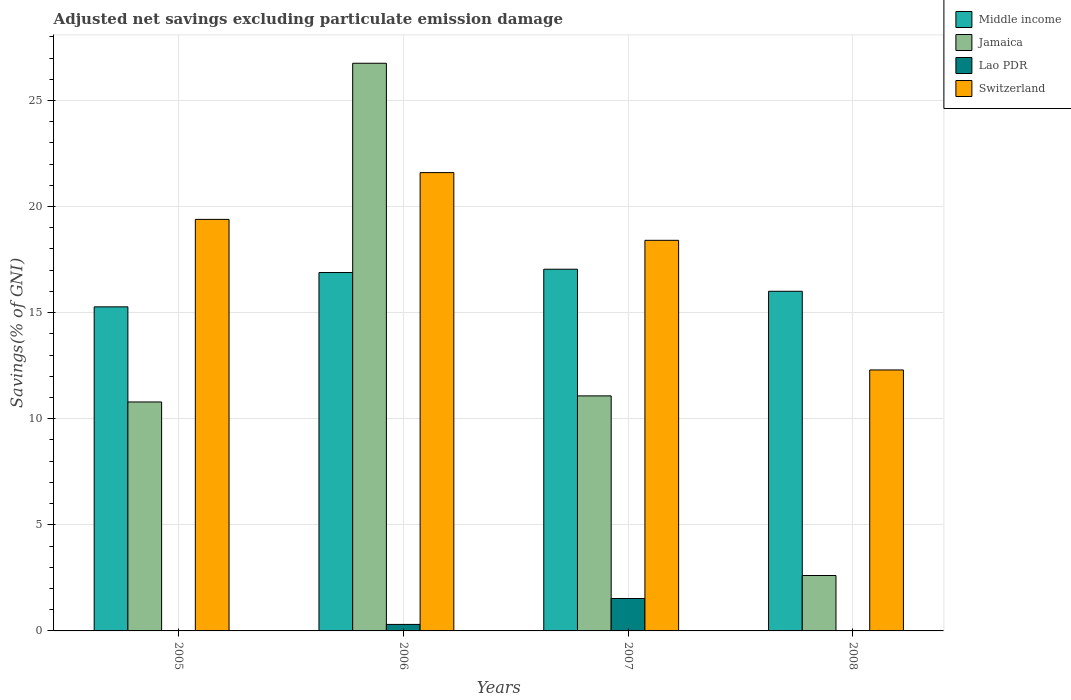How many groups of bars are there?
Your response must be concise. 4. Are the number of bars on each tick of the X-axis equal?
Provide a short and direct response. No. How many bars are there on the 1st tick from the right?
Your response must be concise. 3. In how many cases, is the number of bars for a given year not equal to the number of legend labels?
Provide a succinct answer. 2. What is the adjusted net savings in Switzerland in 2007?
Your answer should be very brief. 18.41. Across all years, what is the maximum adjusted net savings in Switzerland?
Make the answer very short. 21.6. Across all years, what is the minimum adjusted net savings in Jamaica?
Ensure brevity in your answer.  2.61. In which year was the adjusted net savings in Jamaica maximum?
Provide a short and direct response. 2006. What is the total adjusted net savings in Middle income in the graph?
Offer a very short reply. 65.22. What is the difference between the adjusted net savings in Jamaica in 2005 and that in 2007?
Give a very brief answer. -0.29. What is the difference between the adjusted net savings in Jamaica in 2008 and the adjusted net savings in Middle income in 2006?
Offer a terse response. -14.28. What is the average adjusted net savings in Jamaica per year?
Your response must be concise. 12.81. In the year 2006, what is the difference between the adjusted net savings in Jamaica and adjusted net savings in Middle income?
Your answer should be very brief. 9.86. In how many years, is the adjusted net savings in Middle income greater than 25 %?
Ensure brevity in your answer.  0. What is the ratio of the adjusted net savings in Middle income in 2006 to that in 2008?
Offer a terse response. 1.06. Is the adjusted net savings in Jamaica in 2005 less than that in 2006?
Your answer should be very brief. Yes. What is the difference between the highest and the second highest adjusted net savings in Jamaica?
Your answer should be very brief. 15.68. What is the difference between the highest and the lowest adjusted net savings in Middle income?
Your answer should be very brief. 1.77. Is it the case that in every year, the sum of the adjusted net savings in Switzerland and adjusted net savings in Middle income is greater than the sum of adjusted net savings in Lao PDR and adjusted net savings in Jamaica?
Your answer should be very brief. No. Is it the case that in every year, the sum of the adjusted net savings in Middle income and adjusted net savings in Switzerland is greater than the adjusted net savings in Lao PDR?
Your response must be concise. Yes. Are all the bars in the graph horizontal?
Ensure brevity in your answer.  No. What is the difference between two consecutive major ticks on the Y-axis?
Ensure brevity in your answer.  5. Does the graph contain any zero values?
Make the answer very short. Yes. Does the graph contain grids?
Give a very brief answer. Yes. How are the legend labels stacked?
Provide a succinct answer. Vertical. What is the title of the graph?
Your answer should be compact. Adjusted net savings excluding particulate emission damage. What is the label or title of the Y-axis?
Provide a succinct answer. Savings(% of GNI). What is the Savings(% of GNI) in Middle income in 2005?
Offer a terse response. 15.27. What is the Savings(% of GNI) in Jamaica in 2005?
Keep it short and to the point. 10.79. What is the Savings(% of GNI) of Switzerland in 2005?
Provide a short and direct response. 19.4. What is the Savings(% of GNI) of Middle income in 2006?
Ensure brevity in your answer.  16.89. What is the Savings(% of GNI) of Jamaica in 2006?
Your answer should be compact. 26.75. What is the Savings(% of GNI) in Lao PDR in 2006?
Provide a short and direct response. 0.31. What is the Savings(% of GNI) in Switzerland in 2006?
Your response must be concise. 21.6. What is the Savings(% of GNI) in Middle income in 2007?
Provide a short and direct response. 17.05. What is the Savings(% of GNI) of Jamaica in 2007?
Offer a very short reply. 11.08. What is the Savings(% of GNI) in Lao PDR in 2007?
Your answer should be very brief. 1.53. What is the Savings(% of GNI) of Switzerland in 2007?
Make the answer very short. 18.41. What is the Savings(% of GNI) of Middle income in 2008?
Your answer should be compact. 16.01. What is the Savings(% of GNI) of Jamaica in 2008?
Ensure brevity in your answer.  2.61. What is the Savings(% of GNI) in Switzerland in 2008?
Provide a succinct answer. 12.3. Across all years, what is the maximum Savings(% of GNI) of Middle income?
Your answer should be compact. 17.05. Across all years, what is the maximum Savings(% of GNI) in Jamaica?
Your answer should be compact. 26.75. Across all years, what is the maximum Savings(% of GNI) of Lao PDR?
Offer a very short reply. 1.53. Across all years, what is the maximum Savings(% of GNI) in Switzerland?
Your answer should be compact. 21.6. Across all years, what is the minimum Savings(% of GNI) in Middle income?
Give a very brief answer. 15.27. Across all years, what is the minimum Savings(% of GNI) in Jamaica?
Offer a terse response. 2.61. Across all years, what is the minimum Savings(% of GNI) of Lao PDR?
Offer a very short reply. 0. Across all years, what is the minimum Savings(% of GNI) of Switzerland?
Ensure brevity in your answer.  12.3. What is the total Savings(% of GNI) in Middle income in the graph?
Make the answer very short. 65.22. What is the total Savings(% of GNI) in Jamaica in the graph?
Give a very brief answer. 51.23. What is the total Savings(% of GNI) in Lao PDR in the graph?
Ensure brevity in your answer.  1.83. What is the total Savings(% of GNI) in Switzerland in the graph?
Offer a terse response. 71.7. What is the difference between the Savings(% of GNI) of Middle income in 2005 and that in 2006?
Your response must be concise. -1.62. What is the difference between the Savings(% of GNI) of Jamaica in 2005 and that in 2006?
Offer a terse response. -15.96. What is the difference between the Savings(% of GNI) in Switzerland in 2005 and that in 2006?
Offer a terse response. -2.2. What is the difference between the Savings(% of GNI) in Middle income in 2005 and that in 2007?
Ensure brevity in your answer.  -1.77. What is the difference between the Savings(% of GNI) of Jamaica in 2005 and that in 2007?
Your response must be concise. -0.29. What is the difference between the Savings(% of GNI) of Switzerland in 2005 and that in 2007?
Offer a very short reply. 0.99. What is the difference between the Savings(% of GNI) in Middle income in 2005 and that in 2008?
Offer a terse response. -0.73. What is the difference between the Savings(% of GNI) of Jamaica in 2005 and that in 2008?
Offer a very short reply. 8.18. What is the difference between the Savings(% of GNI) in Switzerland in 2005 and that in 2008?
Offer a terse response. 7.1. What is the difference between the Savings(% of GNI) of Middle income in 2006 and that in 2007?
Ensure brevity in your answer.  -0.16. What is the difference between the Savings(% of GNI) in Jamaica in 2006 and that in 2007?
Make the answer very short. 15.68. What is the difference between the Savings(% of GNI) in Lao PDR in 2006 and that in 2007?
Your answer should be compact. -1.22. What is the difference between the Savings(% of GNI) in Switzerland in 2006 and that in 2007?
Provide a short and direct response. 3.19. What is the difference between the Savings(% of GNI) in Middle income in 2006 and that in 2008?
Your answer should be compact. 0.88. What is the difference between the Savings(% of GNI) of Jamaica in 2006 and that in 2008?
Ensure brevity in your answer.  24.14. What is the difference between the Savings(% of GNI) of Switzerland in 2006 and that in 2008?
Give a very brief answer. 9.3. What is the difference between the Savings(% of GNI) of Middle income in 2007 and that in 2008?
Give a very brief answer. 1.04. What is the difference between the Savings(% of GNI) of Jamaica in 2007 and that in 2008?
Keep it short and to the point. 8.47. What is the difference between the Savings(% of GNI) of Switzerland in 2007 and that in 2008?
Offer a very short reply. 6.11. What is the difference between the Savings(% of GNI) of Middle income in 2005 and the Savings(% of GNI) of Jamaica in 2006?
Keep it short and to the point. -11.48. What is the difference between the Savings(% of GNI) in Middle income in 2005 and the Savings(% of GNI) in Lao PDR in 2006?
Your response must be concise. 14.97. What is the difference between the Savings(% of GNI) of Middle income in 2005 and the Savings(% of GNI) of Switzerland in 2006?
Your answer should be very brief. -6.33. What is the difference between the Savings(% of GNI) in Jamaica in 2005 and the Savings(% of GNI) in Lao PDR in 2006?
Your answer should be compact. 10.48. What is the difference between the Savings(% of GNI) of Jamaica in 2005 and the Savings(% of GNI) of Switzerland in 2006?
Provide a succinct answer. -10.81. What is the difference between the Savings(% of GNI) in Middle income in 2005 and the Savings(% of GNI) in Jamaica in 2007?
Ensure brevity in your answer.  4.2. What is the difference between the Savings(% of GNI) of Middle income in 2005 and the Savings(% of GNI) of Lao PDR in 2007?
Offer a very short reply. 13.75. What is the difference between the Savings(% of GNI) of Middle income in 2005 and the Savings(% of GNI) of Switzerland in 2007?
Your response must be concise. -3.14. What is the difference between the Savings(% of GNI) in Jamaica in 2005 and the Savings(% of GNI) in Lao PDR in 2007?
Give a very brief answer. 9.26. What is the difference between the Savings(% of GNI) of Jamaica in 2005 and the Savings(% of GNI) of Switzerland in 2007?
Your answer should be very brief. -7.62. What is the difference between the Savings(% of GNI) in Middle income in 2005 and the Savings(% of GNI) in Jamaica in 2008?
Provide a short and direct response. 12.66. What is the difference between the Savings(% of GNI) of Middle income in 2005 and the Savings(% of GNI) of Switzerland in 2008?
Ensure brevity in your answer.  2.97. What is the difference between the Savings(% of GNI) of Jamaica in 2005 and the Savings(% of GNI) of Switzerland in 2008?
Your response must be concise. -1.51. What is the difference between the Savings(% of GNI) of Middle income in 2006 and the Savings(% of GNI) of Jamaica in 2007?
Ensure brevity in your answer.  5.81. What is the difference between the Savings(% of GNI) of Middle income in 2006 and the Savings(% of GNI) of Lao PDR in 2007?
Your response must be concise. 15.36. What is the difference between the Savings(% of GNI) in Middle income in 2006 and the Savings(% of GNI) in Switzerland in 2007?
Keep it short and to the point. -1.52. What is the difference between the Savings(% of GNI) of Jamaica in 2006 and the Savings(% of GNI) of Lao PDR in 2007?
Give a very brief answer. 25.23. What is the difference between the Savings(% of GNI) of Jamaica in 2006 and the Savings(% of GNI) of Switzerland in 2007?
Provide a succinct answer. 8.34. What is the difference between the Savings(% of GNI) in Lao PDR in 2006 and the Savings(% of GNI) in Switzerland in 2007?
Offer a terse response. -18.1. What is the difference between the Savings(% of GNI) in Middle income in 2006 and the Savings(% of GNI) in Jamaica in 2008?
Your response must be concise. 14.28. What is the difference between the Savings(% of GNI) of Middle income in 2006 and the Savings(% of GNI) of Switzerland in 2008?
Offer a very short reply. 4.59. What is the difference between the Savings(% of GNI) in Jamaica in 2006 and the Savings(% of GNI) in Switzerland in 2008?
Ensure brevity in your answer.  14.45. What is the difference between the Savings(% of GNI) of Lao PDR in 2006 and the Savings(% of GNI) of Switzerland in 2008?
Your answer should be very brief. -11.99. What is the difference between the Savings(% of GNI) in Middle income in 2007 and the Savings(% of GNI) in Jamaica in 2008?
Your response must be concise. 14.43. What is the difference between the Savings(% of GNI) in Middle income in 2007 and the Savings(% of GNI) in Switzerland in 2008?
Your response must be concise. 4.75. What is the difference between the Savings(% of GNI) in Jamaica in 2007 and the Savings(% of GNI) in Switzerland in 2008?
Ensure brevity in your answer.  -1.22. What is the difference between the Savings(% of GNI) in Lao PDR in 2007 and the Savings(% of GNI) in Switzerland in 2008?
Provide a succinct answer. -10.77. What is the average Savings(% of GNI) in Middle income per year?
Give a very brief answer. 16.3. What is the average Savings(% of GNI) of Jamaica per year?
Keep it short and to the point. 12.81. What is the average Savings(% of GNI) in Lao PDR per year?
Offer a terse response. 0.46. What is the average Savings(% of GNI) of Switzerland per year?
Provide a succinct answer. 17.93. In the year 2005, what is the difference between the Savings(% of GNI) in Middle income and Savings(% of GNI) in Jamaica?
Offer a very short reply. 4.48. In the year 2005, what is the difference between the Savings(% of GNI) of Middle income and Savings(% of GNI) of Switzerland?
Offer a very short reply. -4.12. In the year 2005, what is the difference between the Savings(% of GNI) of Jamaica and Savings(% of GNI) of Switzerland?
Ensure brevity in your answer.  -8.61. In the year 2006, what is the difference between the Savings(% of GNI) of Middle income and Savings(% of GNI) of Jamaica?
Make the answer very short. -9.86. In the year 2006, what is the difference between the Savings(% of GNI) of Middle income and Savings(% of GNI) of Lao PDR?
Give a very brief answer. 16.58. In the year 2006, what is the difference between the Savings(% of GNI) of Middle income and Savings(% of GNI) of Switzerland?
Offer a very short reply. -4.71. In the year 2006, what is the difference between the Savings(% of GNI) in Jamaica and Savings(% of GNI) in Lao PDR?
Your answer should be very brief. 26.45. In the year 2006, what is the difference between the Savings(% of GNI) of Jamaica and Savings(% of GNI) of Switzerland?
Your response must be concise. 5.15. In the year 2006, what is the difference between the Savings(% of GNI) of Lao PDR and Savings(% of GNI) of Switzerland?
Your answer should be very brief. -21.29. In the year 2007, what is the difference between the Savings(% of GNI) of Middle income and Savings(% of GNI) of Jamaica?
Your response must be concise. 5.97. In the year 2007, what is the difference between the Savings(% of GNI) of Middle income and Savings(% of GNI) of Lao PDR?
Your response must be concise. 15.52. In the year 2007, what is the difference between the Savings(% of GNI) in Middle income and Savings(% of GNI) in Switzerland?
Make the answer very short. -1.36. In the year 2007, what is the difference between the Savings(% of GNI) in Jamaica and Savings(% of GNI) in Lao PDR?
Your response must be concise. 9.55. In the year 2007, what is the difference between the Savings(% of GNI) of Jamaica and Savings(% of GNI) of Switzerland?
Provide a succinct answer. -7.33. In the year 2007, what is the difference between the Savings(% of GNI) in Lao PDR and Savings(% of GNI) in Switzerland?
Ensure brevity in your answer.  -16.88. In the year 2008, what is the difference between the Savings(% of GNI) in Middle income and Savings(% of GNI) in Jamaica?
Ensure brevity in your answer.  13.4. In the year 2008, what is the difference between the Savings(% of GNI) in Middle income and Savings(% of GNI) in Switzerland?
Offer a very short reply. 3.71. In the year 2008, what is the difference between the Savings(% of GNI) of Jamaica and Savings(% of GNI) of Switzerland?
Your answer should be compact. -9.69. What is the ratio of the Savings(% of GNI) in Middle income in 2005 to that in 2006?
Offer a terse response. 0.9. What is the ratio of the Savings(% of GNI) of Jamaica in 2005 to that in 2006?
Provide a succinct answer. 0.4. What is the ratio of the Savings(% of GNI) of Switzerland in 2005 to that in 2006?
Make the answer very short. 0.9. What is the ratio of the Savings(% of GNI) in Middle income in 2005 to that in 2007?
Offer a very short reply. 0.9. What is the ratio of the Savings(% of GNI) in Jamaica in 2005 to that in 2007?
Offer a very short reply. 0.97. What is the ratio of the Savings(% of GNI) of Switzerland in 2005 to that in 2007?
Make the answer very short. 1.05. What is the ratio of the Savings(% of GNI) of Middle income in 2005 to that in 2008?
Provide a succinct answer. 0.95. What is the ratio of the Savings(% of GNI) of Jamaica in 2005 to that in 2008?
Offer a very short reply. 4.13. What is the ratio of the Savings(% of GNI) in Switzerland in 2005 to that in 2008?
Provide a succinct answer. 1.58. What is the ratio of the Savings(% of GNI) in Jamaica in 2006 to that in 2007?
Offer a terse response. 2.42. What is the ratio of the Savings(% of GNI) of Lao PDR in 2006 to that in 2007?
Make the answer very short. 0.2. What is the ratio of the Savings(% of GNI) in Switzerland in 2006 to that in 2007?
Your response must be concise. 1.17. What is the ratio of the Savings(% of GNI) in Middle income in 2006 to that in 2008?
Give a very brief answer. 1.06. What is the ratio of the Savings(% of GNI) of Jamaica in 2006 to that in 2008?
Offer a terse response. 10.24. What is the ratio of the Savings(% of GNI) in Switzerland in 2006 to that in 2008?
Ensure brevity in your answer.  1.76. What is the ratio of the Savings(% of GNI) of Middle income in 2007 to that in 2008?
Give a very brief answer. 1.06. What is the ratio of the Savings(% of GNI) in Jamaica in 2007 to that in 2008?
Provide a short and direct response. 4.24. What is the ratio of the Savings(% of GNI) of Switzerland in 2007 to that in 2008?
Provide a succinct answer. 1.5. What is the difference between the highest and the second highest Savings(% of GNI) in Middle income?
Make the answer very short. 0.16. What is the difference between the highest and the second highest Savings(% of GNI) of Jamaica?
Offer a very short reply. 15.68. What is the difference between the highest and the second highest Savings(% of GNI) of Switzerland?
Keep it short and to the point. 2.2. What is the difference between the highest and the lowest Savings(% of GNI) of Middle income?
Ensure brevity in your answer.  1.77. What is the difference between the highest and the lowest Savings(% of GNI) of Jamaica?
Ensure brevity in your answer.  24.14. What is the difference between the highest and the lowest Savings(% of GNI) in Lao PDR?
Provide a short and direct response. 1.53. What is the difference between the highest and the lowest Savings(% of GNI) of Switzerland?
Your response must be concise. 9.3. 